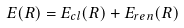<formula> <loc_0><loc_0><loc_500><loc_500>E ( R ) = E _ { c l } ( R ) + E _ { r e n } ( R )</formula> 